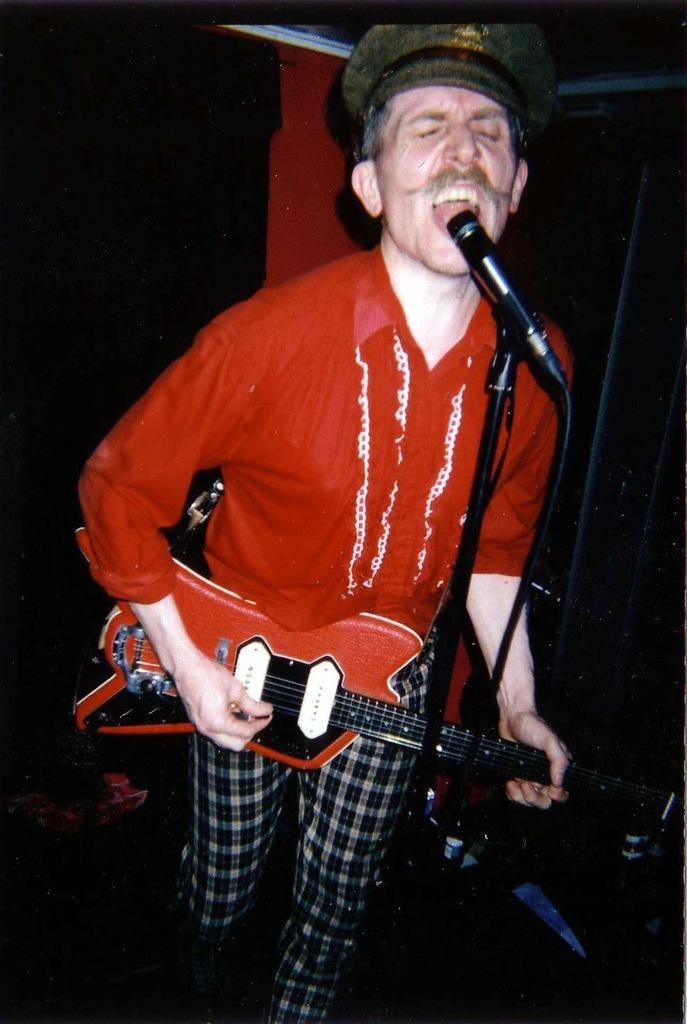In one or two sentences, can you explain what this image depicts? In this picture we can see a man holding guitar and singing, there is a microphone in front of him we can see a microphone stand here. 